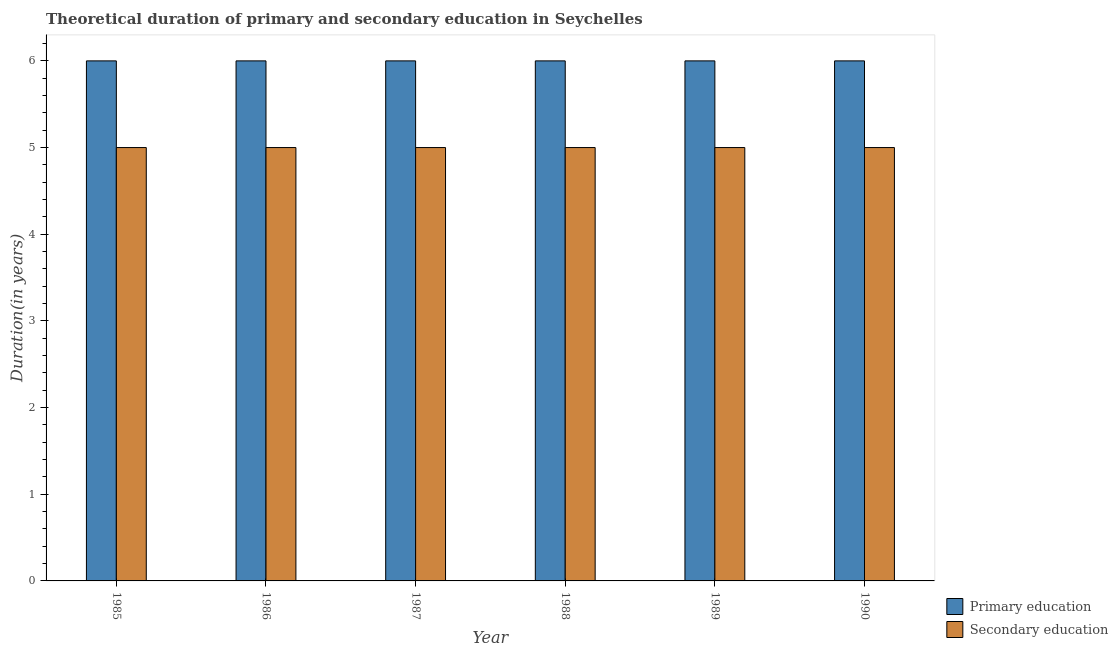How many different coloured bars are there?
Give a very brief answer. 2. How many groups of bars are there?
Your answer should be very brief. 6. Are the number of bars per tick equal to the number of legend labels?
Your answer should be compact. Yes. Are the number of bars on each tick of the X-axis equal?
Keep it short and to the point. Yes. What is the label of the 6th group of bars from the left?
Ensure brevity in your answer.  1990. What is the duration of primary education in 1985?
Offer a very short reply. 6. Across all years, what is the maximum duration of secondary education?
Keep it short and to the point. 5. Across all years, what is the minimum duration of primary education?
Ensure brevity in your answer.  6. In which year was the duration of primary education minimum?
Your response must be concise. 1985. What is the total duration of secondary education in the graph?
Make the answer very short. 30. What is the average duration of primary education per year?
Your response must be concise. 6. In the year 1988, what is the difference between the duration of secondary education and duration of primary education?
Your answer should be very brief. 0. What is the ratio of the duration of primary education in 1986 to that in 1988?
Offer a very short reply. 1. What is the difference between the highest and the second highest duration of primary education?
Offer a terse response. 0. What is the difference between the highest and the lowest duration of primary education?
Ensure brevity in your answer.  0. Is the sum of the duration of secondary education in 1986 and 1989 greater than the maximum duration of primary education across all years?
Make the answer very short. Yes. What does the 2nd bar from the left in 1989 represents?
Offer a terse response. Secondary education. What does the 2nd bar from the right in 1990 represents?
Your answer should be very brief. Primary education. Are all the bars in the graph horizontal?
Offer a very short reply. No. Are the values on the major ticks of Y-axis written in scientific E-notation?
Provide a succinct answer. No. Does the graph contain any zero values?
Your answer should be very brief. No. Where does the legend appear in the graph?
Your answer should be very brief. Bottom right. How are the legend labels stacked?
Your response must be concise. Vertical. What is the title of the graph?
Your response must be concise. Theoretical duration of primary and secondary education in Seychelles. What is the label or title of the Y-axis?
Provide a succinct answer. Duration(in years). What is the Duration(in years) of Primary education in 1986?
Ensure brevity in your answer.  6. What is the Duration(in years) of Secondary education in 1986?
Offer a terse response. 5. What is the Duration(in years) in Primary education in 1987?
Make the answer very short. 6. What is the Duration(in years) of Secondary education in 1987?
Provide a succinct answer. 5. What is the Duration(in years) in Secondary education in 1989?
Your response must be concise. 5. Across all years, what is the maximum Duration(in years) in Primary education?
Your response must be concise. 6. Across all years, what is the minimum Duration(in years) of Secondary education?
Offer a terse response. 5. What is the total Duration(in years) in Primary education in the graph?
Keep it short and to the point. 36. What is the total Duration(in years) in Secondary education in the graph?
Your answer should be very brief. 30. What is the difference between the Duration(in years) in Primary education in 1985 and that in 1986?
Your answer should be compact. 0. What is the difference between the Duration(in years) in Secondary education in 1985 and that in 1986?
Offer a terse response. 0. What is the difference between the Duration(in years) in Primary education in 1985 and that in 1987?
Provide a succinct answer. 0. What is the difference between the Duration(in years) in Secondary education in 1985 and that in 1987?
Your answer should be compact. 0. What is the difference between the Duration(in years) of Primary education in 1985 and that in 1988?
Your response must be concise. 0. What is the difference between the Duration(in years) of Primary education in 1986 and that in 1987?
Make the answer very short. 0. What is the difference between the Duration(in years) of Primary education in 1986 and that in 1988?
Offer a terse response. 0. What is the difference between the Duration(in years) in Secondary education in 1986 and that in 1988?
Your response must be concise. 0. What is the difference between the Duration(in years) of Primary education in 1986 and that in 1989?
Keep it short and to the point. 0. What is the difference between the Duration(in years) in Primary education in 1987 and that in 1988?
Keep it short and to the point. 0. What is the difference between the Duration(in years) of Secondary education in 1987 and that in 1988?
Your answer should be compact. 0. What is the difference between the Duration(in years) in Primary education in 1987 and that in 1989?
Your response must be concise. 0. What is the difference between the Duration(in years) of Primary education in 1987 and that in 1990?
Ensure brevity in your answer.  0. What is the difference between the Duration(in years) of Secondary education in 1987 and that in 1990?
Give a very brief answer. 0. What is the difference between the Duration(in years) in Primary education in 1988 and that in 1989?
Make the answer very short. 0. What is the difference between the Duration(in years) in Secondary education in 1988 and that in 1989?
Your response must be concise. 0. What is the difference between the Duration(in years) in Secondary education in 1988 and that in 1990?
Provide a succinct answer. 0. What is the difference between the Duration(in years) in Primary education in 1985 and the Duration(in years) in Secondary education in 1986?
Keep it short and to the point. 1. What is the difference between the Duration(in years) of Primary education in 1985 and the Duration(in years) of Secondary education in 1987?
Give a very brief answer. 1. What is the difference between the Duration(in years) of Primary education in 1985 and the Duration(in years) of Secondary education in 1988?
Your answer should be compact. 1. What is the difference between the Duration(in years) in Primary education in 1985 and the Duration(in years) in Secondary education in 1989?
Your answer should be compact. 1. What is the difference between the Duration(in years) of Primary education in 1985 and the Duration(in years) of Secondary education in 1990?
Make the answer very short. 1. What is the difference between the Duration(in years) of Primary education in 1986 and the Duration(in years) of Secondary education in 1987?
Offer a terse response. 1. What is the difference between the Duration(in years) in Primary education in 1986 and the Duration(in years) in Secondary education in 1988?
Your answer should be compact. 1. What is the difference between the Duration(in years) in Primary education in 1987 and the Duration(in years) in Secondary education in 1988?
Ensure brevity in your answer.  1. What is the difference between the Duration(in years) in Primary education in 1987 and the Duration(in years) in Secondary education in 1989?
Keep it short and to the point. 1. In the year 1985, what is the difference between the Duration(in years) in Primary education and Duration(in years) in Secondary education?
Your answer should be compact. 1. In the year 1987, what is the difference between the Duration(in years) of Primary education and Duration(in years) of Secondary education?
Give a very brief answer. 1. In the year 1988, what is the difference between the Duration(in years) of Primary education and Duration(in years) of Secondary education?
Make the answer very short. 1. What is the ratio of the Duration(in years) in Secondary education in 1985 to that in 1986?
Make the answer very short. 1. What is the ratio of the Duration(in years) in Secondary education in 1985 to that in 1987?
Offer a very short reply. 1. What is the ratio of the Duration(in years) in Secondary education in 1985 to that in 1988?
Make the answer very short. 1. What is the ratio of the Duration(in years) in Primary education in 1985 to that in 1989?
Your response must be concise. 1. What is the ratio of the Duration(in years) of Primary education in 1986 to that in 1987?
Your answer should be compact. 1. What is the ratio of the Duration(in years) of Secondary education in 1986 to that in 1988?
Offer a terse response. 1. What is the ratio of the Duration(in years) in Primary education in 1986 to that in 1989?
Give a very brief answer. 1. What is the ratio of the Duration(in years) in Primary education in 1986 to that in 1990?
Keep it short and to the point. 1. What is the ratio of the Duration(in years) of Primary education in 1987 to that in 1988?
Your answer should be very brief. 1. What is the ratio of the Duration(in years) in Secondary education in 1987 to that in 1988?
Your answer should be very brief. 1. What is the ratio of the Duration(in years) in Primary education in 1987 to that in 1989?
Provide a succinct answer. 1. What is the ratio of the Duration(in years) in Secondary education in 1987 to that in 1989?
Your answer should be compact. 1. What is the ratio of the Duration(in years) in Secondary education in 1987 to that in 1990?
Give a very brief answer. 1. What is the ratio of the Duration(in years) in Primary education in 1988 to that in 1989?
Offer a terse response. 1. What is the ratio of the Duration(in years) of Secondary education in 1988 to that in 1989?
Keep it short and to the point. 1. What is the ratio of the Duration(in years) in Primary education in 1988 to that in 1990?
Provide a short and direct response. 1. What is the ratio of the Duration(in years) in Secondary education in 1989 to that in 1990?
Make the answer very short. 1. What is the difference between the highest and the second highest Duration(in years) in Primary education?
Make the answer very short. 0. What is the difference between the highest and the lowest Duration(in years) in Primary education?
Offer a terse response. 0. What is the difference between the highest and the lowest Duration(in years) of Secondary education?
Your response must be concise. 0. 